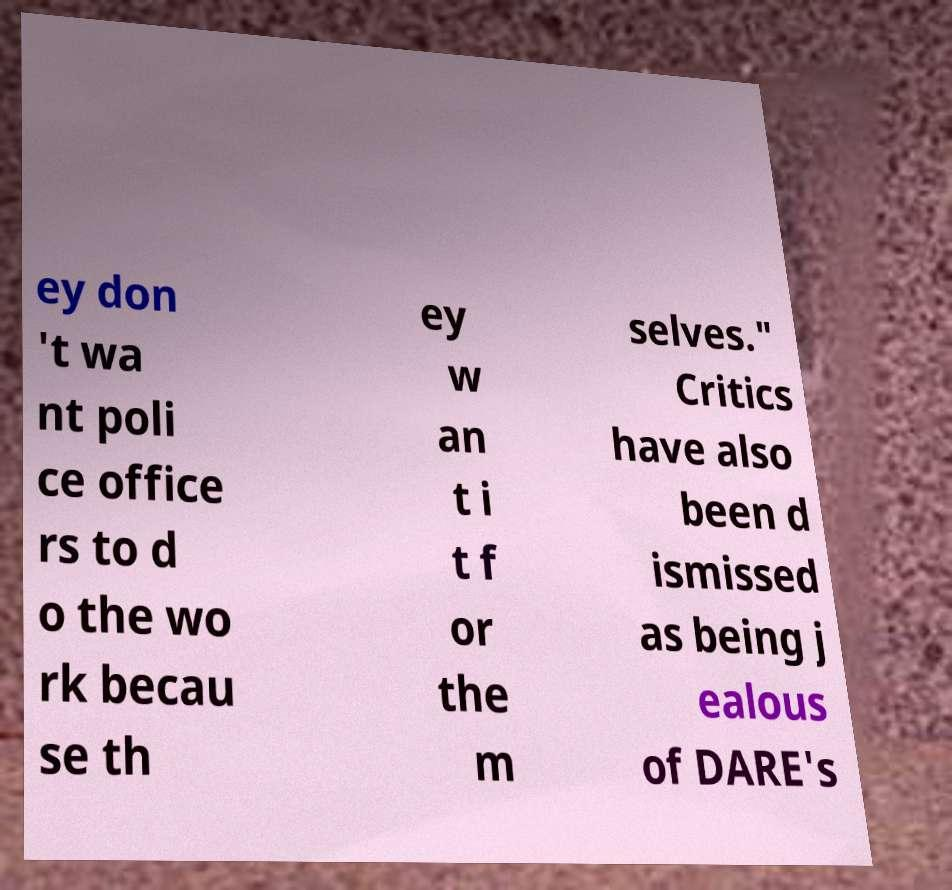For documentation purposes, I need the text within this image transcribed. Could you provide that? ey don 't wa nt poli ce office rs to d o the wo rk becau se th ey w an t i t f or the m selves." Critics have also been d ismissed as being j ealous of DARE's 